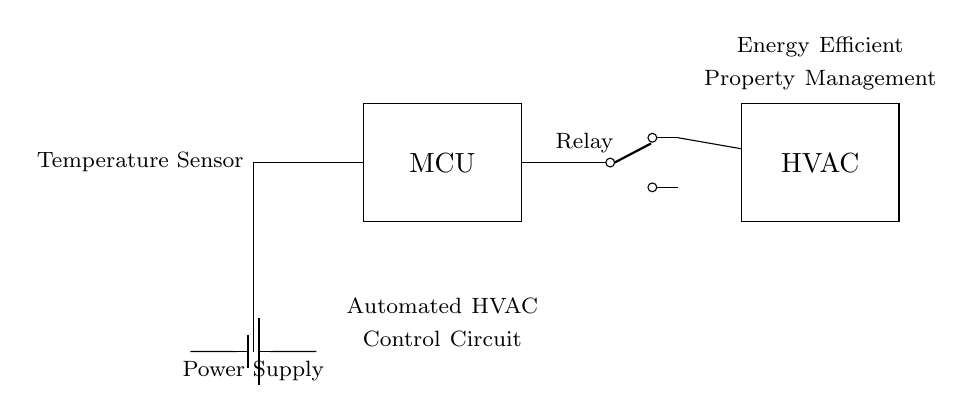What component is used to measure temperature? The component labeled as "Temperature Sensor" in the diagram is used to measure the temperature. It is represented by a thermistor symbol, which is commonly used for temperature sensing in circuits.
Answer: Temperature Sensor What does MCU stand for? The acronym "MCU" in the circuit diagram stands for Microcontroller Unit. It is the central control unit that processes the signals received from the temperature sensor through the ADC.
Answer: Microcontroller Unit Which component controls the HVAC system? The component that controls the HVAC system is the relay, which is depicted as a switch in the circuit diagram. The relay receives input from the microcontroller and switches the HVAC system on or off based on the temperature readings.
Answer: Relay How many main components are connected to the power supply? The power supply is connected to three main components: the microcontroller (MCU), the relay, and indirectly to the HVAC system through the relay. This establishes the control over the HVAC operation and its functionalities.
Answer: Three What is the role of the ADC in the circuit? The ADC, or Analog to Digital Converter, in this circuit converts the analog signal from the temperature sensor into a digital signal that can be processed by the microcontroller. This step is crucial for enabling the MCU to understand the temperature readings accurately.
Answer: Analog to Digital Converter What powers the entire circuit? The entire circuit is powered by the battery, which is indicated as the power supply in the diagram. It provides the necessary voltage for all components, including the temperature sensor, microcontroller, relay, and HVAC system.
Answer: Battery What type of circuit is shown in the diagram? The circuit depicted in the diagram is an automated control circuit specifically designed for HVAC systems aimed at enhancing energy efficiency in properties. It integrates various components including sensors and control units to optimize HVAC operations.
Answer: Automated Control Circuit 